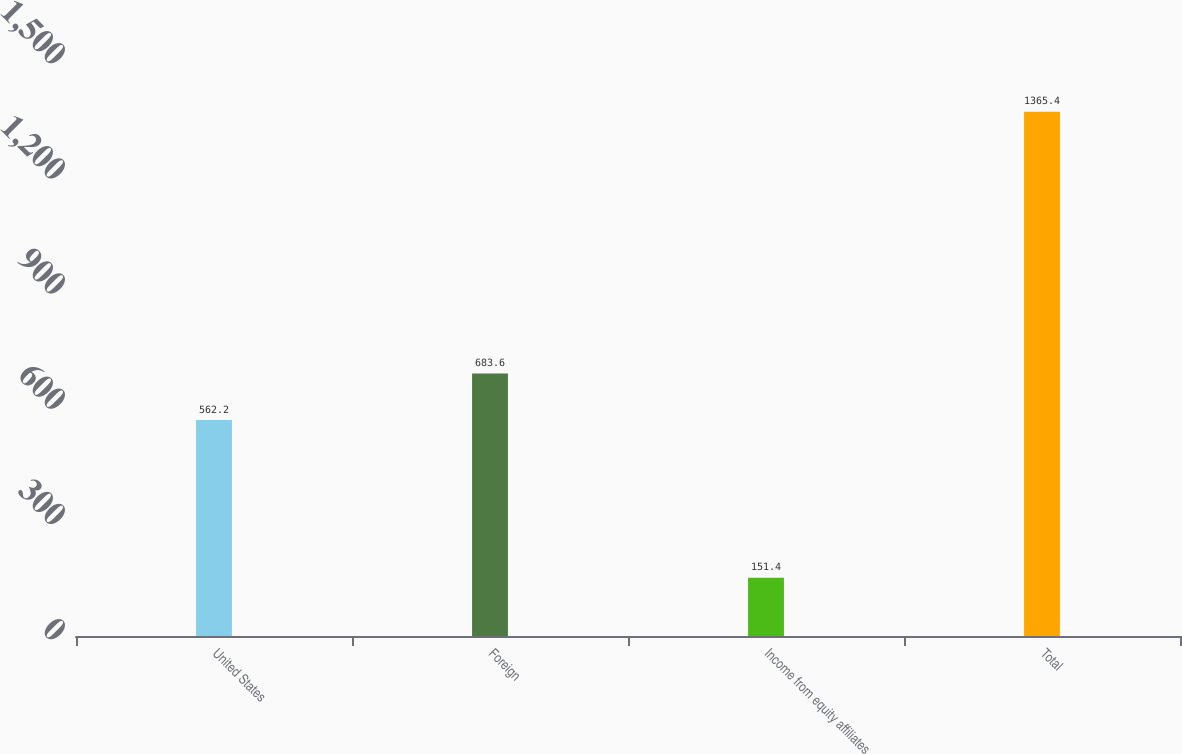<chart> <loc_0><loc_0><loc_500><loc_500><bar_chart><fcel>United States<fcel>Foreign<fcel>Income from equity affiliates<fcel>Total<nl><fcel>562.2<fcel>683.6<fcel>151.4<fcel>1365.4<nl></chart> 